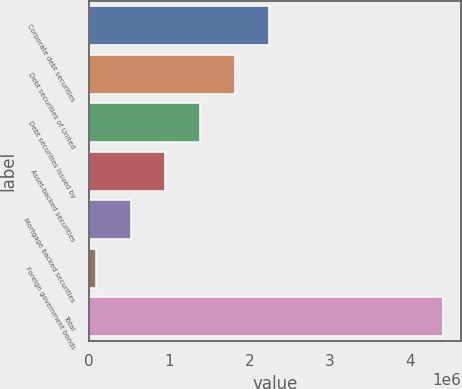<chart> <loc_0><loc_0><loc_500><loc_500><bar_chart><fcel>Corporate debt securities<fcel>Debt securities of United<fcel>Debt securities issued by<fcel>Asset-backed securities<fcel>Mortgage backed securities<fcel>Foreign government bonds<fcel>Total<nl><fcel>2.24889e+06<fcel>1.81607e+06<fcel>1.38325e+06<fcel>950435<fcel>517618<fcel>84800<fcel>4.41298e+06<nl></chart> 